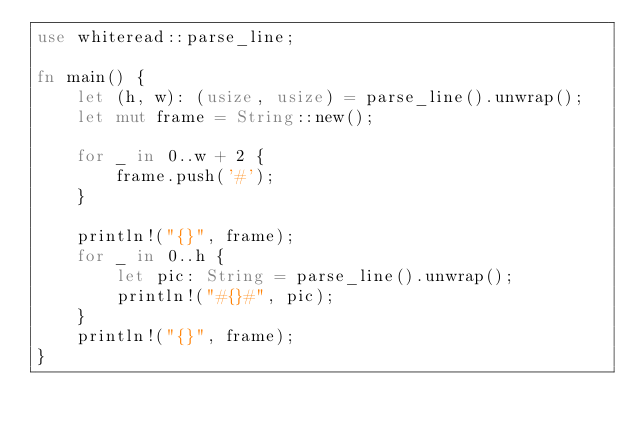<code> <loc_0><loc_0><loc_500><loc_500><_Rust_>use whiteread::parse_line;

fn main() {
    let (h, w): (usize, usize) = parse_line().unwrap();
    let mut frame = String::new();

    for _ in 0..w + 2 {
        frame.push('#');
    }

    println!("{}", frame);
    for _ in 0..h {
        let pic: String = parse_line().unwrap();
        println!("#{}#", pic);
    }
    println!("{}", frame);
}
</code> 